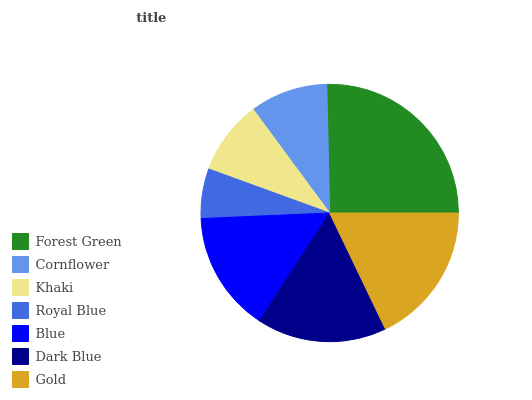Is Royal Blue the minimum?
Answer yes or no. Yes. Is Forest Green the maximum?
Answer yes or no. Yes. Is Cornflower the minimum?
Answer yes or no. No. Is Cornflower the maximum?
Answer yes or no. No. Is Forest Green greater than Cornflower?
Answer yes or no. Yes. Is Cornflower less than Forest Green?
Answer yes or no. Yes. Is Cornflower greater than Forest Green?
Answer yes or no. No. Is Forest Green less than Cornflower?
Answer yes or no. No. Is Blue the high median?
Answer yes or no. Yes. Is Blue the low median?
Answer yes or no. Yes. Is Forest Green the high median?
Answer yes or no. No. Is Forest Green the low median?
Answer yes or no. No. 